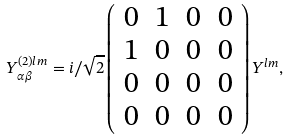Convert formula to latex. <formula><loc_0><loc_0><loc_500><loc_500>Y ^ { ( 2 ) l m } _ { \alpha \beta } = i / \sqrt { 2 } \left ( \begin{array} { c c c c } 0 & 1 & 0 & 0 \\ 1 & 0 & 0 & 0 \\ 0 & 0 & 0 & 0 \\ 0 & 0 & 0 & 0 \end{array} \right ) Y ^ { l m } ,</formula> 